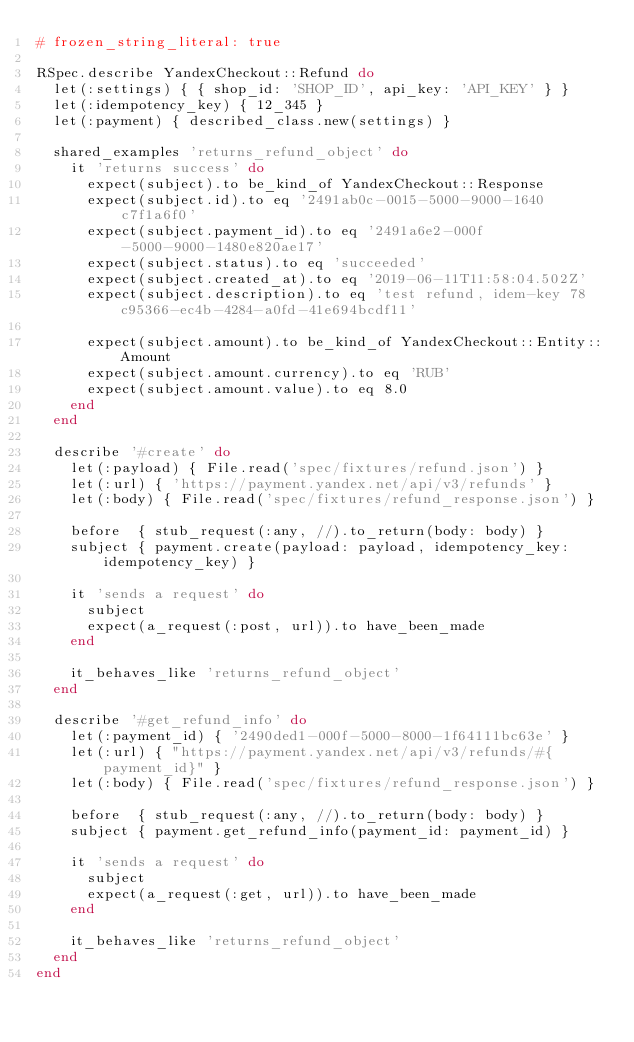<code> <loc_0><loc_0><loc_500><loc_500><_Ruby_># frozen_string_literal: true

RSpec.describe YandexCheckout::Refund do
  let(:settings) { { shop_id: 'SHOP_ID', api_key: 'API_KEY' } }
  let(:idempotency_key) { 12_345 }
  let(:payment) { described_class.new(settings) }

  shared_examples 'returns_refund_object' do
    it 'returns success' do
      expect(subject).to be_kind_of YandexCheckout::Response
      expect(subject.id).to eq '2491ab0c-0015-5000-9000-1640c7f1a6f0'
      expect(subject.payment_id).to eq '2491a6e2-000f-5000-9000-1480e820ae17'
      expect(subject.status).to eq 'succeeded'
      expect(subject.created_at).to eq '2019-06-11T11:58:04.502Z'
      expect(subject.description).to eq 'test refund, idem-key 78c95366-ec4b-4284-a0fd-41e694bcdf11'

      expect(subject.amount).to be_kind_of YandexCheckout::Entity::Amount
      expect(subject.amount.currency).to eq 'RUB'
      expect(subject.amount.value).to eq 8.0
    end
  end

  describe '#create' do
    let(:payload) { File.read('spec/fixtures/refund.json') }
    let(:url) { 'https://payment.yandex.net/api/v3/refunds' }
    let(:body) { File.read('spec/fixtures/refund_response.json') }

    before  { stub_request(:any, //).to_return(body: body) }
    subject { payment.create(payload: payload, idempotency_key: idempotency_key) }

    it 'sends a request' do
      subject
      expect(a_request(:post, url)).to have_been_made
    end

    it_behaves_like 'returns_refund_object'
  end

  describe '#get_refund_info' do
    let(:payment_id) { '2490ded1-000f-5000-8000-1f64111bc63e' }
    let(:url) { "https://payment.yandex.net/api/v3/refunds/#{payment_id}" }
    let(:body) { File.read('spec/fixtures/refund_response.json') }

    before  { stub_request(:any, //).to_return(body: body) }
    subject { payment.get_refund_info(payment_id: payment_id) }

    it 'sends a request' do
      subject
      expect(a_request(:get, url)).to have_been_made
    end

    it_behaves_like 'returns_refund_object'
  end
end
</code> 